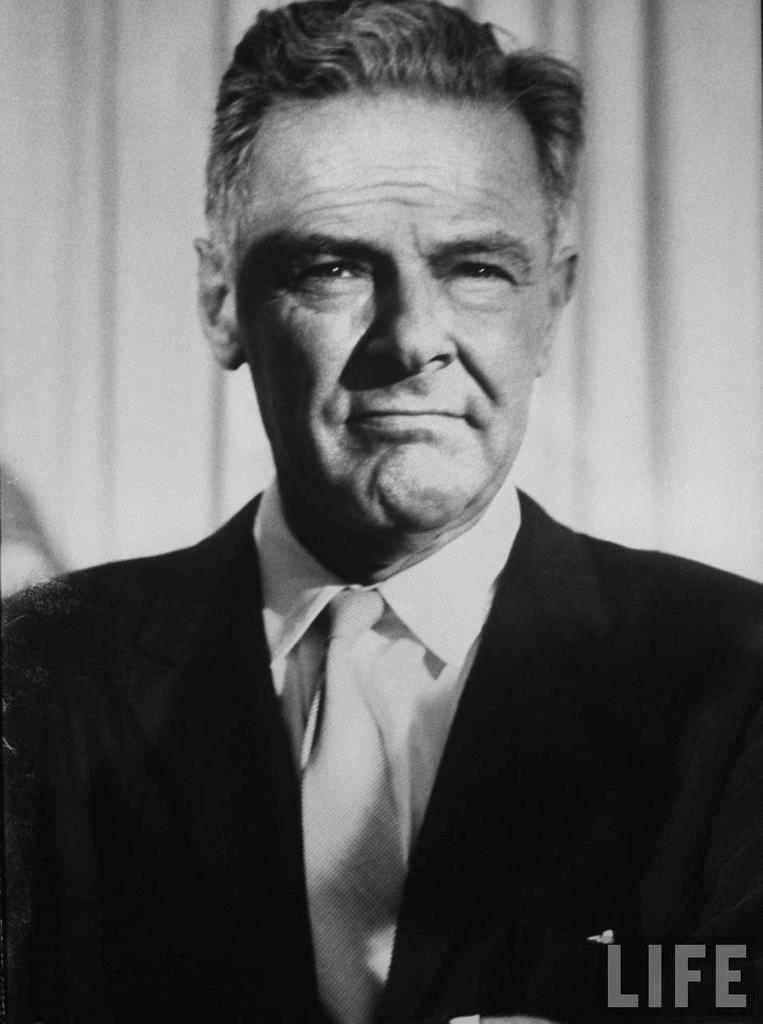Can you describe this image briefly? In the picture I can see a man. The man is wearing a tie, a shirt and a coat. On the bottom right corner of the image I can see a watermark. This picture is black and white in color. 